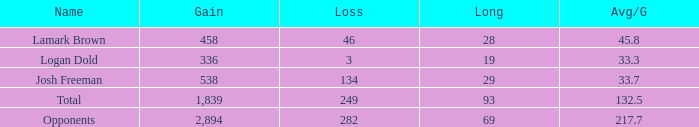Which Avg/G has a Long of 93, and a Loss smaller than 249? None. 